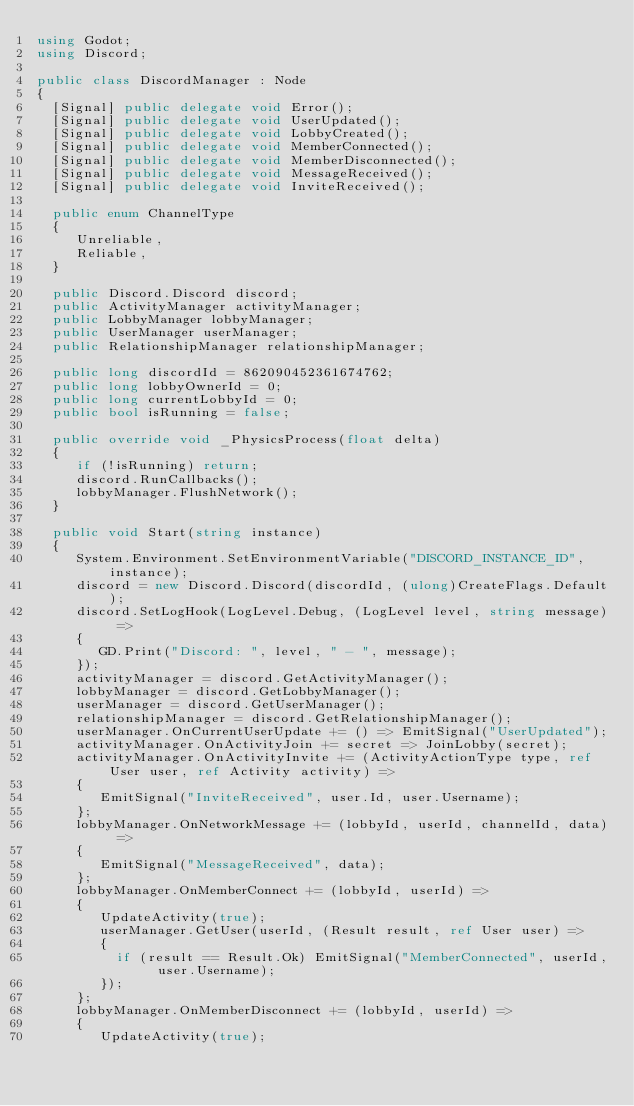Convert code to text. <code><loc_0><loc_0><loc_500><loc_500><_C#_>using Godot;
using Discord;

public class DiscordManager : Node
{
  [Signal] public delegate void Error();
  [Signal] public delegate void UserUpdated();
  [Signal] public delegate void LobbyCreated();
  [Signal] public delegate void MemberConnected();
  [Signal] public delegate void MemberDisconnected();
  [Signal] public delegate void MessageReceived();
  [Signal] public delegate void InviteReceived();

  public enum ChannelType
  {
	 Unreliable,
	 Reliable,
  }

  public Discord.Discord discord;
  public ActivityManager activityManager;
  public LobbyManager lobbyManager;
  public UserManager userManager;
  public RelationshipManager relationshipManager;

  public long discordId = 862090452361674762;
  public long lobbyOwnerId = 0;
  public long currentLobbyId = 0;
  public bool isRunning = false;

  public override void _PhysicsProcess(float delta)
  {
	 if (!isRunning) return;
	 discord.RunCallbacks();
	 lobbyManager.FlushNetwork();
  }

  public void Start(string instance)
  {
	 System.Environment.SetEnvironmentVariable("DISCORD_INSTANCE_ID", instance);
	 discord = new Discord.Discord(discordId, (ulong)CreateFlags.Default);
	 discord.SetLogHook(LogLevel.Debug, (LogLevel level, string message) =>
	 {
		GD.Print("Discord: ", level, " - ", message);
	 });
	 activityManager = discord.GetActivityManager();
	 lobbyManager = discord.GetLobbyManager();
	 userManager = discord.GetUserManager();
	 relationshipManager = discord.GetRelationshipManager();
	 userManager.OnCurrentUserUpdate += () => EmitSignal("UserUpdated");
	 activityManager.OnActivityJoin += secret => JoinLobby(secret);
	 activityManager.OnActivityInvite += (ActivityActionType type, ref User user, ref Activity activity) =>
	 {
		EmitSignal("InviteReceived", user.Id, user.Username);
	 };
	 lobbyManager.OnNetworkMessage += (lobbyId, userId, channelId, data) =>
	 {
		EmitSignal("MessageReceived", data);
	 };
	 lobbyManager.OnMemberConnect += (lobbyId, userId) =>
	 {
		UpdateActivity(true);
		userManager.GetUser(userId, (Result result, ref User user) =>
		{
		  if (result == Result.Ok) EmitSignal("MemberConnected", userId, user.Username);
		});
	 };
	 lobbyManager.OnMemberDisconnect += (lobbyId, userId) =>
	 {
		UpdateActivity(true);</code> 